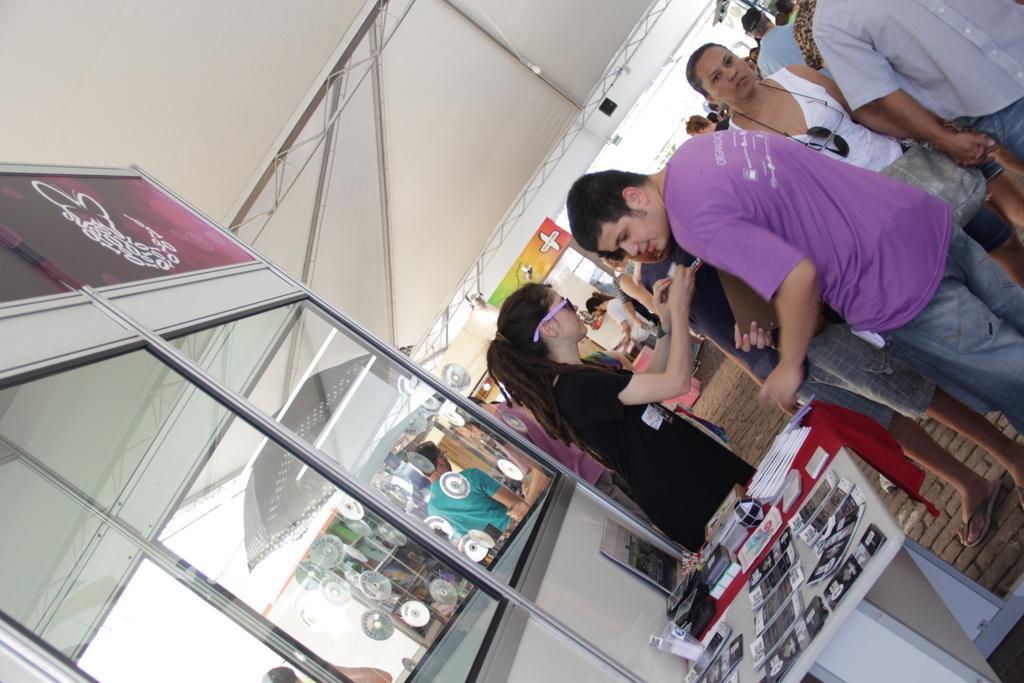Could you give a brief overview of what you see in this image? This image consists of many people. To the left, there is a cabin. Beside that there is a table on which there are many papers kept. The girl is wearing black dress. At the top, there is a tent. 